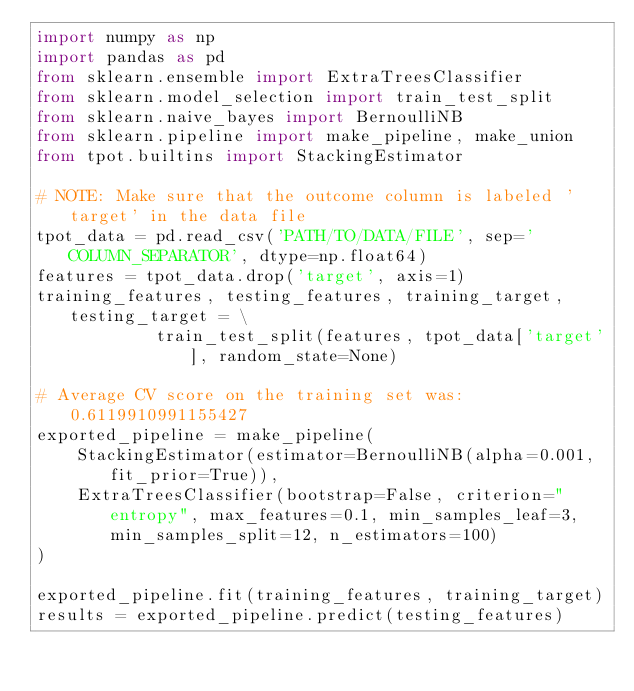<code> <loc_0><loc_0><loc_500><loc_500><_Python_>import numpy as np
import pandas as pd
from sklearn.ensemble import ExtraTreesClassifier
from sklearn.model_selection import train_test_split
from sklearn.naive_bayes import BernoulliNB
from sklearn.pipeline import make_pipeline, make_union
from tpot.builtins import StackingEstimator

# NOTE: Make sure that the outcome column is labeled 'target' in the data file
tpot_data = pd.read_csv('PATH/TO/DATA/FILE', sep='COLUMN_SEPARATOR', dtype=np.float64)
features = tpot_data.drop('target', axis=1)
training_features, testing_features, training_target, testing_target = \
            train_test_split(features, tpot_data['target'], random_state=None)

# Average CV score on the training set was: 0.6119910991155427
exported_pipeline = make_pipeline(
    StackingEstimator(estimator=BernoulliNB(alpha=0.001, fit_prior=True)),
    ExtraTreesClassifier(bootstrap=False, criterion="entropy", max_features=0.1, min_samples_leaf=3, min_samples_split=12, n_estimators=100)
)

exported_pipeline.fit(training_features, training_target)
results = exported_pipeline.predict(testing_features)
</code> 